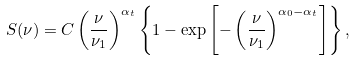Convert formula to latex. <formula><loc_0><loc_0><loc_500><loc_500>S ( \nu ) = C \left ( \frac { \nu } { \nu _ { 1 } } \right ) ^ { \alpha _ { t } } \left \{ 1 - \exp \left [ - \left ( \frac { \nu } { \nu _ { 1 } } \right ) ^ { \alpha _ { 0 } - \alpha _ { t } } \right ] \right \} ,</formula> 